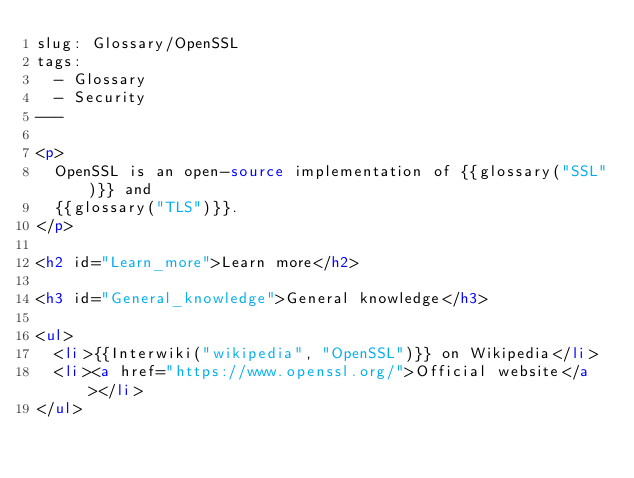<code> <loc_0><loc_0><loc_500><loc_500><_HTML_>slug: Glossary/OpenSSL
tags:
  - Glossary
  - Security
---

<p>
  OpenSSL is an open-source implementation of {{glossary("SSL")}} and
  {{glossary("TLS")}}.
</p>

<h2 id="Learn_more">Learn more</h2>

<h3 id="General_knowledge">General knowledge</h3>

<ul>
  <li>{{Interwiki("wikipedia", "OpenSSL")}} on Wikipedia</li>
  <li><a href="https://www.openssl.org/">Official website</a></li>
</ul>
</code> 